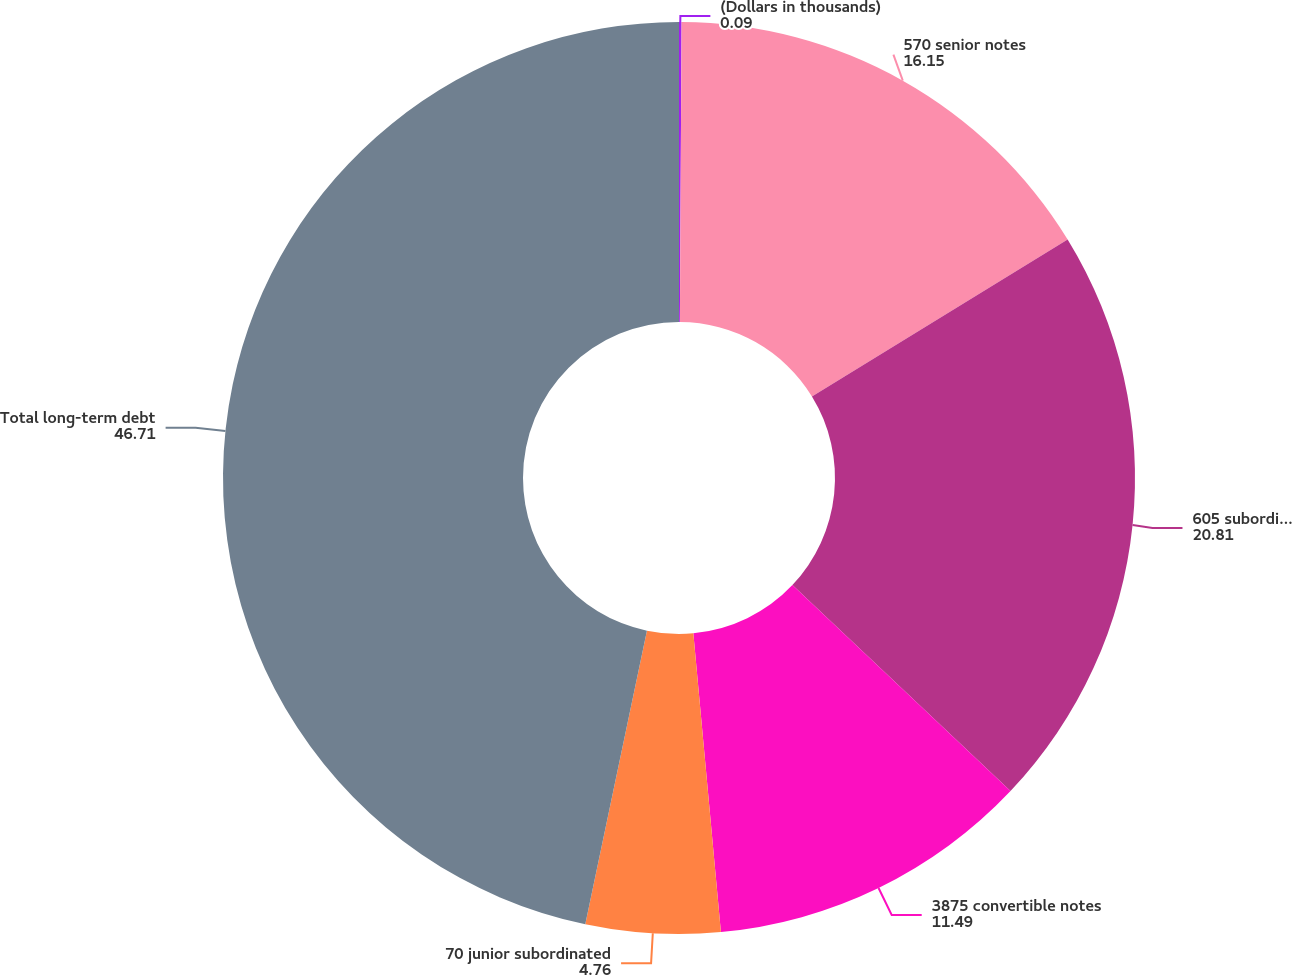Convert chart to OTSL. <chart><loc_0><loc_0><loc_500><loc_500><pie_chart><fcel>(Dollars in thousands)<fcel>570 senior notes<fcel>605 subordinated notes<fcel>3875 convertible notes<fcel>70 junior subordinated<fcel>Total long-term debt<nl><fcel>0.09%<fcel>16.15%<fcel>20.81%<fcel>11.49%<fcel>4.76%<fcel>46.71%<nl></chart> 